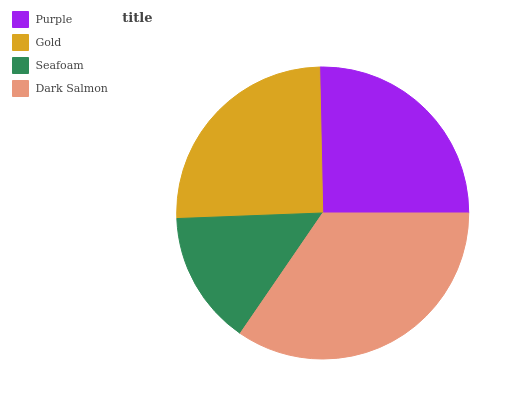Is Seafoam the minimum?
Answer yes or no. Yes. Is Dark Salmon the maximum?
Answer yes or no. Yes. Is Gold the minimum?
Answer yes or no. No. Is Gold the maximum?
Answer yes or no. No. Is Purple greater than Gold?
Answer yes or no. Yes. Is Gold less than Purple?
Answer yes or no. Yes. Is Gold greater than Purple?
Answer yes or no. No. Is Purple less than Gold?
Answer yes or no. No. Is Purple the high median?
Answer yes or no. Yes. Is Gold the low median?
Answer yes or no. Yes. Is Seafoam the high median?
Answer yes or no. No. Is Seafoam the low median?
Answer yes or no. No. 